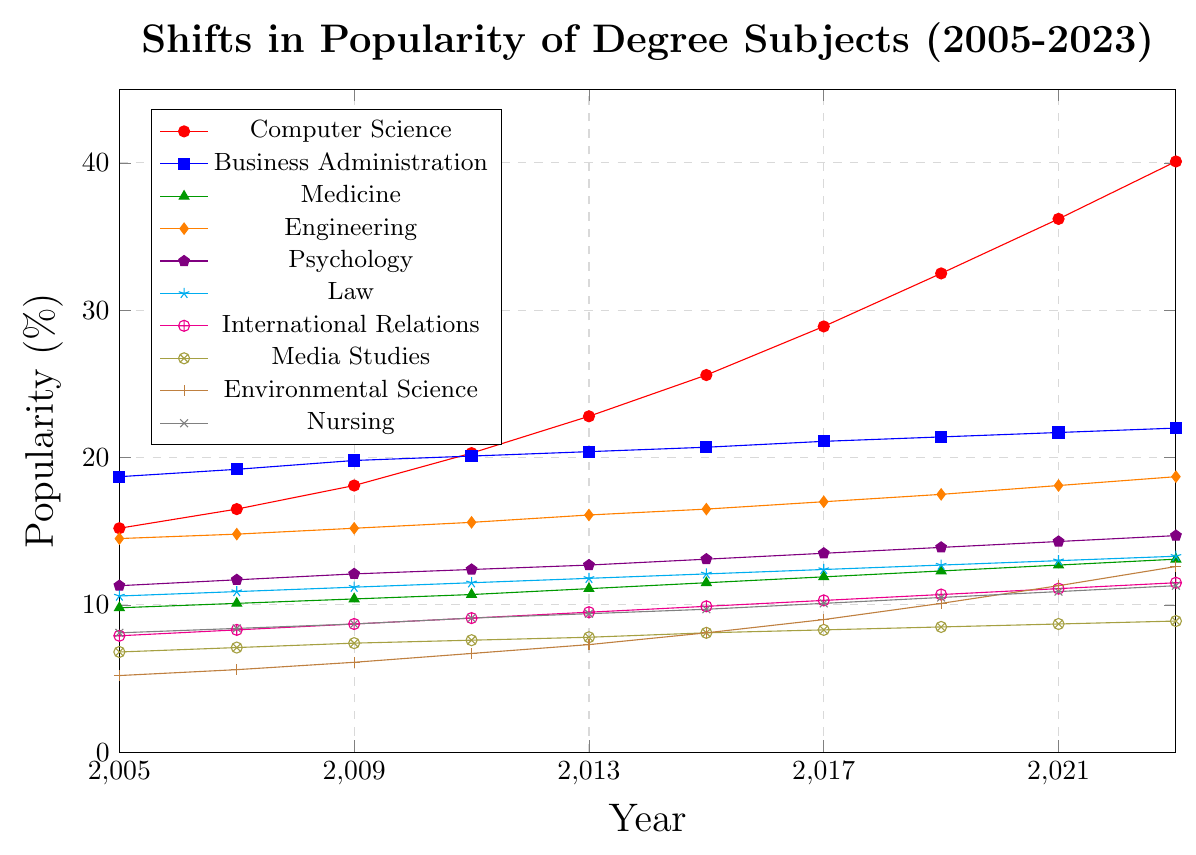How has the popularity of Computer Science compared to Engineering changed from 2005 to 2023? Computer Science started at 15.2% in 2005 and increased to 40.1% in 2023. Engineering started at 14.5% in 2005 and increased to 18.7% in 2023.
Answer: Computer Science increased more rapidly than Engineering Which degree subject had the most consistent increase in popularity over the years without any decline? Business Administration increased steadily from 18.7% in 2005 to 22.0% in 2023 without any drop in percentage over the years.
Answer: Business Administration By how many percentage points did the popularity of Environmental Science increase from 2005 to 2023? The popularity of Environmental Science in 2005 was 5.2%, and in 2023 it was 12.6%. The increase is 12.6% - 5.2%.
Answer: 7.4 percentage points Which degree subject showed the highest popularity as of 2023? In 2023, Computer Science is at 40.1%, which is the highest among all the subjects listed in the data.
Answer: Computer Science In which year did the popularity of Nursing surpass 10%? The popularity of Nursing surpassed 10% in the year 2017, as it was 10.1% in that year.
Answer: 2017 How did the popularity of International Relations change from 2005 to 2015? International Relations increased from 7.9% in 2005 to 9.9% in 2015.
Answer: Increased by 2 percentage points Which year saw Computer Science surpass 20% in popularity? Computer Science surpassed 20% in popularity in the year 2011 when it reached 20.3%.
Answer: 2011 What was the percentage increase for Medicine from 2005 to 2023? Medicine had a popularity of 9.8% in 2005 and 13.1% in 2023. The percentage increase is ((13.1 - 9.8) / 9.8) * 100%.
Answer: 33.7% Which subject witnessed the smallest percentage increase in popularity from 2005 to 2023? Business Administration saw an increase from 18.7% in 2005 to 22.0% in 2023, which is the smallest increase compared to the other subjects.
Answer: Business Administration 